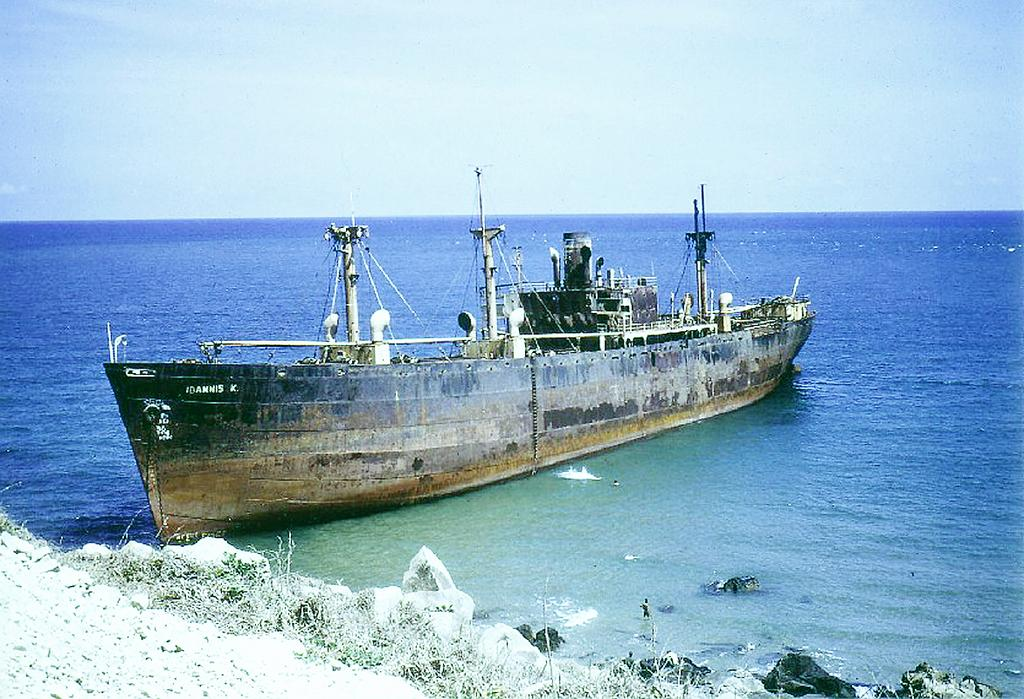What is the main subject of the image? There is a ship in the image. What is the ship's location in relation to the water? The ship is floating on the water. What type of natural features can be seen in the image? There are rocks and grass visible in the image. What can be seen in the background of the image? The sky is visible in the background of the image. What type of soda is being served on the ship in the image? There is no soda visible in the image, and it is not mentioned in the provided facts. What type of pleasure activity is taking place on the ship in the image? The provided facts do not mention any specific pleasure activity taking place on the ship. 